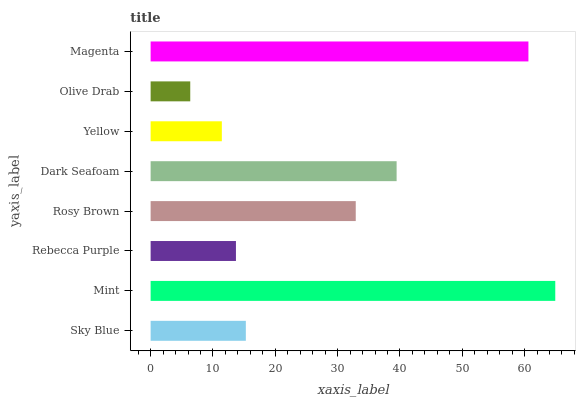Is Olive Drab the minimum?
Answer yes or no. Yes. Is Mint the maximum?
Answer yes or no. Yes. Is Rebecca Purple the minimum?
Answer yes or no. No. Is Rebecca Purple the maximum?
Answer yes or no. No. Is Mint greater than Rebecca Purple?
Answer yes or no. Yes. Is Rebecca Purple less than Mint?
Answer yes or no. Yes. Is Rebecca Purple greater than Mint?
Answer yes or no. No. Is Mint less than Rebecca Purple?
Answer yes or no. No. Is Rosy Brown the high median?
Answer yes or no. Yes. Is Sky Blue the low median?
Answer yes or no. Yes. Is Olive Drab the high median?
Answer yes or no. No. Is Rebecca Purple the low median?
Answer yes or no. No. 